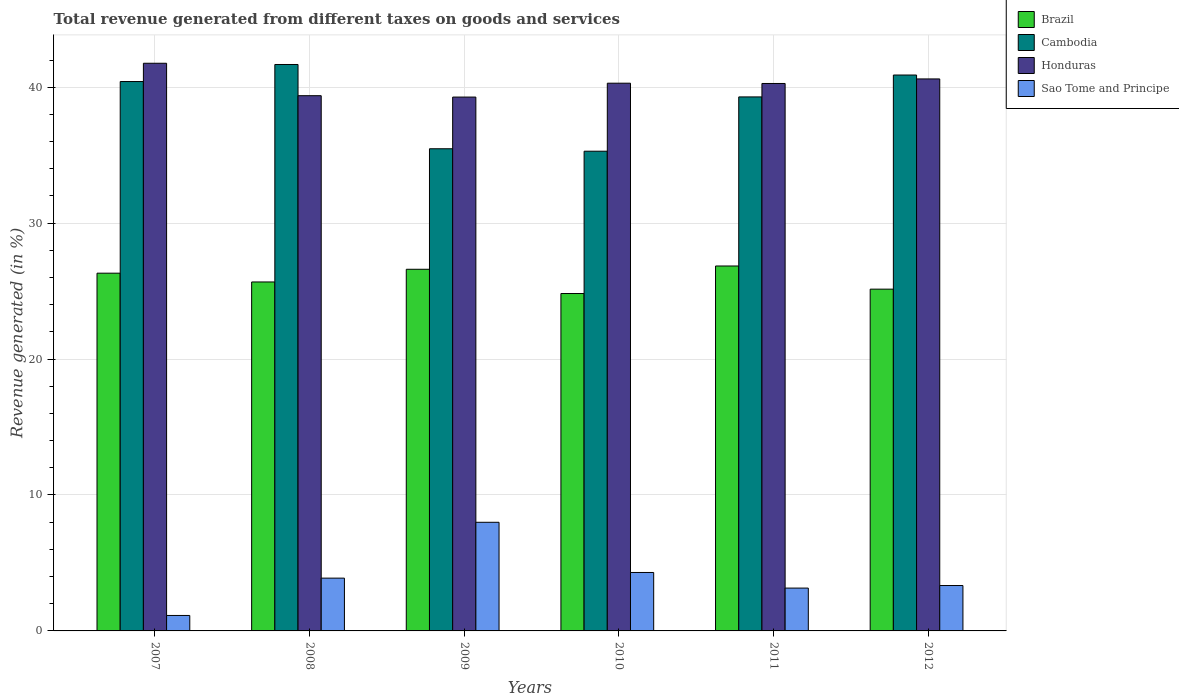How many groups of bars are there?
Your answer should be compact. 6. Are the number of bars on each tick of the X-axis equal?
Give a very brief answer. Yes. What is the label of the 1st group of bars from the left?
Your answer should be compact. 2007. What is the total revenue generated in Cambodia in 2008?
Your answer should be compact. 41.67. Across all years, what is the maximum total revenue generated in Cambodia?
Keep it short and to the point. 41.67. Across all years, what is the minimum total revenue generated in Sao Tome and Principe?
Provide a short and direct response. 1.14. In which year was the total revenue generated in Cambodia maximum?
Ensure brevity in your answer.  2008. In which year was the total revenue generated in Cambodia minimum?
Your response must be concise. 2010. What is the total total revenue generated in Honduras in the graph?
Give a very brief answer. 241.58. What is the difference between the total revenue generated in Cambodia in 2009 and that in 2012?
Your answer should be very brief. -5.42. What is the difference between the total revenue generated in Cambodia in 2008 and the total revenue generated in Honduras in 2010?
Your response must be concise. 1.38. What is the average total revenue generated in Sao Tome and Principe per year?
Make the answer very short. 3.97. In the year 2012, what is the difference between the total revenue generated in Brazil and total revenue generated in Honduras?
Your response must be concise. -15.47. What is the ratio of the total revenue generated in Brazil in 2011 to that in 2012?
Offer a terse response. 1.07. Is the total revenue generated in Honduras in 2008 less than that in 2011?
Offer a very short reply. Yes. What is the difference between the highest and the second highest total revenue generated in Honduras?
Keep it short and to the point. 1.15. What is the difference between the highest and the lowest total revenue generated in Cambodia?
Offer a very short reply. 6.38. In how many years, is the total revenue generated in Cambodia greater than the average total revenue generated in Cambodia taken over all years?
Ensure brevity in your answer.  4. Is it the case that in every year, the sum of the total revenue generated in Sao Tome and Principe and total revenue generated in Cambodia is greater than the sum of total revenue generated in Honduras and total revenue generated in Brazil?
Provide a short and direct response. No. What does the 3rd bar from the left in 2010 represents?
Your response must be concise. Honduras. What does the 2nd bar from the right in 2009 represents?
Offer a very short reply. Honduras. Is it the case that in every year, the sum of the total revenue generated in Brazil and total revenue generated in Honduras is greater than the total revenue generated in Cambodia?
Make the answer very short. Yes. How many bars are there?
Keep it short and to the point. 24. Are all the bars in the graph horizontal?
Provide a short and direct response. No. How many years are there in the graph?
Ensure brevity in your answer.  6. Are the values on the major ticks of Y-axis written in scientific E-notation?
Offer a very short reply. No. Does the graph contain any zero values?
Give a very brief answer. No. Does the graph contain grids?
Offer a terse response. Yes. How are the legend labels stacked?
Offer a terse response. Vertical. What is the title of the graph?
Your answer should be very brief. Total revenue generated from different taxes on goods and services. Does "Honduras" appear as one of the legend labels in the graph?
Give a very brief answer. Yes. What is the label or title of the X-axis?
Ensure brevity in your answer.  Years. What is the label or title of the Y-axis?
Ensure brevity in your answer.  Revenue generated (in %). What is the Revenue generated (in %) in Brazil in 2007?
Offer a terse response. 26.32. What is the Revenue generated (in %) of Cambodia in 2007?
Keep it short and to the point. 40.42. What is the Revenue generated (in %) in Honduras in 2007?
Your answer should be compact. 41.76. What is the Revenue generated (in %) of Sao Tome and Principe in 2007?
Your answer should be compact. 1.14. What is the Revenue generated (in %) in Brazil in 2008?
Provide a succinct answer. 25.67. What is the Revenue generated (in %) of Cambodia in 2008?
Make the answer very short. 41.67. What is the Revenue generated (in %) of Honduras in 2008?
Provide a succinct answer. 39.37. What is the Revenue generated (in %) in Sao Tome and Principe in 2008?
Offer a terse response. 3.88. What is the Revenue generated (in %) of Brazil in 2009?
Provide a short and direct response. 26.61. What is the Revenue generated (in %) of Cambodia in 2009?
Ensure brevity in your answer.  35.47. What is the Revenue generated (in %) of Honduras in 2009?
Give a very brief answer. 39.27. What is the Revenue generated (in %) in Sao Tome and Principe in 2009?
Your response must be concise. 7.99. What is the Revenue generated (in %) of Brazil in 2010?
Provide a succinct answer. 24.82. What is the Revenue generated (in %) in Cambodia in 2010?
Offer a terse response. 35.29. What is the Revenue generated (in %) of Honduras in 2010?
Offer a terse response. 40.29. What is the Revenue generated (in %) of Sao Tome and Principe in 2010?
Your response must be concise. 4.3. What is the Revenue generated (in %) of Brazil in 2011?
Keep it short and to the point. 26.85. What is the Revenue generated (in %) of Cambodia in 2011?
Give a very brief answer. 39.28. What is the Revenue generated (in %) of Honduras in 2011?
Keep it short and to the point. 40.27. What is the Revenue generated (in %) of Sao Tome and Principe in 2011?
Provide a succinct answer. 3.15. What is the Revenue generated (in %) of Brazil in 2012?
Your answer should be very brief. 25.14. What is the Revenue generated (in %) of Cambodia in 2012?
Your response must be concise. 40.9. What is the Revenue generated (in %) of Honduras in 2012?
Ensure brevity in your answer.  40.61. What is the Revenue generated (in %) of Sao Tome and Principe in 2012?
Offer a terse response. 3.34. Across all years, what is the maximum Revenue generated (in %) in Brazil?
Offer a very short reply. 26.85. Across all years, what is the maximum Revenue generated (in %) of Cambodia?
Keep it short and to the point. 41.67. Across all years, what is the maximum Revenue generated (in %) in Honduras?
Provide a short and direct response. 41.76. Across all years, what is the maximum Revenue generated (in %) of Sao Tome and Principe?
Provide a short and direct response. 7.99. Across all years, what is the minimum Revenue generated (in %) in Brazil?
Offer a terse response. 24.82. Across all years, what is the minimum Revenue generated (in %) in Cambodia?
Give a very brief answer. 35.29. Across all years, what is the minimum Revenue generated (in %) of Honduras?
Your answer should be compact. 39.27. Across all years, what is the minimum Revenue generated (in %) in Sao Tome and Principe?
Your answer should be very brief. 1.14. What is the total Revenue generated (in %) in Brazil in the graph?
Offer a very short reply. 155.4. What is the total Revenue generated (in %) in Cambodia in the graph?
Offer a terse response. 233.03. What is the total Revenue generated (in %) in Honduras in the graph?
Your answer should be compact. 241.58. What is the total Revenue generated (in %) in Sao Tome and Principe in the graph?
Your answer should be compact. 23.8. What is the difference between the Revenue generated (in %) of Brazil in 2007 and that in 2008?
Your answer should be compact. 0.65. What is the difference between the Revenue generated (in %) in Cambodia in 2007 and that in 2008?
Keep it short and to the point. -1.25. What is the difference between the Revenue generated (in %) in Honduras in 2007 and that in 2008?
Give a very brief answer. 2.39. What is the difference between the Revenue generated (in %) of Sao Tome and Principe in 2007 and that in 2008?
Offer a terse response. -2.75. What is the difference between the Revenue generated (in %) of Brazil in 2007 and that in 2009?
Provide a short and direct response. -0.29. What is the difference between the Revenue generated (in %) of Cambodia in 2007 and that in 2009?
Your answer should be compact. 4.95. What is the difference between the Revenue generated (in %) in Honduras in 2007 and that in 2009?
Your response must be concise. 2.49. What is the difference between the Revenue generated (in %) of Sao Tome and Principe in 2007 and that in 2009?
Your response must be concise. -6.85. What is the difference between the Revenue generated (in %) of Brazil in 2007 and that in 2010?
Provide a succinct answer. 1.5. What is the difference between the Revenue generated (in %) in Cambodia in 2007 and that in 2010?
Make the answer very short. 5.13. What is the difference between the Revenue generated (in %) in Honduras in 2007 and that in 2010?
Your answer should be very brief. 1.47. What is the difference between the Revenue generated (in %) in Sao Tome and Principe in 2007 and that in 2010?
Provide a short and direct response. -3.16. What is the difference between the Revenue generated (in %) in Brazil in 2007 and that in 2011?
Your response must be concise. -0.53. What is the difference between the Revenue generated (in %) in Cambodia in 2007 and that in 2011?
Your answer should be compact. 1.13. What is the difference between the Revenue generated (in %) of Honduras in 2007 and that in 2011?
Provide a short and direct response. 1.49. What is the difference between the Revenue generated (in %) in Sao Tome and Principe in 2007 and that in 2011?
Make the answer very short. -2.01. What is the difference between the Revenue generated (in %) of Brazil in 2007 and that in 2012?
Your response must be concise. 1.17. What is the difference between the Revenue generated (in %) of Cambodia in 2007 and that in 2012?
Give a very brief answer. -0.48. What is the difference between the Revenue generated (in %) of Honduras in 2007 and that in 2012?
Your response must be concise. 1.15. What is the difference between the Revenue generated (in %) of Sao Tome and Principe in 2007 and that in 2012?
Your answer should be very brief. -2.2. What is the difference between the Revenue generated (in %) of Brazil in 2008 and that in 2009?
Give a very brief answer. -0.93. What is the difference between the Revenue generated (in %) of Cambodia in 2008 and that in 2009?
Provide a succinct answer. 6.2. What is the difference between the Revenue generated (in %) of Honduras in 2008 and that in 2009?
Give a very brief answer. 0.1. What is the difference between the Revenue generated (in %) of Sao Tome and Principe in 2008 and that in 2009?
Offer a very short reply. -4.11. What is the difference between the Revenue generated (in %) of Brazil in 2008 and that in 2010?
Provide a short and direct response. 0.85. What is the difference between the Revenue generated (in %) in Cambodia in 2008 and that in 2010?
Offer a terse response. 6.38. What is the difference between the Revenue generated (in %) in Honduras in 2008 and that in 2010?
Your answer should be compact. -0.92. What is the difference between the Revenue generated (in %) of Sao Tome and Principe in 2008 and that in 2010?
Offer a very short reply. -0.42. What is the difference between the Revenue generated (in %) of Brazil in 2008 and that in 2011?
Your answer should be very brief. -1.18. What is the difference between the Revenue generated (in %) of Cambodia in 2008 and that in 2011?
Ensure brevity in your answer.  2.39. What is the difference between the Revenue generated (in %) in Honduras in 2008 and that in 2011?
Offer a terse response. -0.9. What is the difference between the Revenue generated (in %) of Sao Tome and Principe in 2008 and that in 2011?
Provide a succinct answer. 0.73. What is the difference between the Revenue generated (in %) in Brazil in 2008 and that in 2012?
Your answer should be compact. 0.53. What is the difference between the Revenue generated (in %) of Cambodia in 2008 and that in 2012?
Your response must be concise. 0.78. What is the difference between the Revenue generated (in %) in Honduras in 2008 and that in 2012?
Provide a short and direct response. -1.23. What is the difference between the Revenue generated (in %) of Sao Tome and Principe in 2008 and that in 2012?
Provide a succinct answer. 0.54. What is the difference between the Revenue generated (in %) of Brazil in 2009 and that in 2010?
Your answer should be compact. 1.78. What is the difference between the Revenue generated (in %) in Cambodia in 2009 and that in 2010?
Offer a very short reply. 0.18. What is the difference between the Revenue generated (in %) in Honduras in 2009 and that in 2010?
Your response must be concise. -1.02. What is the difference between the Revenue generated (in %) in Sao Tome and Principe in 2009 and that in 2010?
Offer a terse response. 3.69. What is the difference between the Revenue generated (in %) in Brazil in 2009 and that in 2011?
Provide a short and direct response. -0.24. What is the difference between the Revenue generated (in %) of Cambodia in 2009 and that in 2011?
Offer a terse response. -3.81. What is the difference between the Revenue generated (in %) of Honduras in 2009 and that in 2011?
Offer a very short reply. -1. What is the difference between the Revenue generated (in %) of Sao Tome and Principe in 2009 and that in 2011?
Provide a short and direct response. 4.84. What is the difference between the Revenue generated (in %) in Brazil in 2009 and that in 2012?
Offer a terse response. 1.46. What is the difference between the Revenue generated (in %) of Cambodia in 2009 and that in 2012?
Provide a short and direct response. -5.42. What is the difference between the Revenue generated (in %) in Honduras in 2009 and that in 2012?
Your response must be concise. -1.34. What is the difference between the Revenue generated (in %) of Sao Tome and Principe in 2009 and that in 2012?
Offer a terse response. 4.65. What is the difference between the Revenue generated (in %) of Brazil in 2010 and that in 2011?
Provide a succinct answer. -2.03. What is the difference between the Revenue generated (in %) of Cambodia in 2010 and that in 2011?
Make the answer very short. -3.99. What is the difference between the Revenue generated (in %) of Honduras in 2010 and that in 2011?
Your answer should be very brief. 0.02. What is the difference between the Revenue generated (in %) of Sao Tome and Principe in 2010 and that in 2011?
Ensure brevity in your answer.  1.15. What is the difference between the Revenue generated (in %) of Brazil in 2010 and that in 2012?
Ensure brevity in your answer.  -0.32. What is the difference between the Revenue generated (in %) in Cambodia in 2010 and that in 2012?
Your response must be concise. -5.6. What is the difference between the Revenue generated (in %) of Honduras in 2010 and that in 2012?
Offer a terse response. -0.31. What is the difference between the Revenue generated (in %) of Sao Tome and Principe in 2010 and that in 2012?
Your answer should be compact. 0.96. What is the difference between the Revenue generated (in %) in Brazil in 2011 and that in 2012?
Give a very brief answer. 1.7. What is the difference between the Revenue generated (in %) in Cambodia in 2011 and that in 2012?
Your answer should be very brief. -1.61. What is the difference between the Revenue generated (in %) in Honduras in 2011 and that in 2012?
Your answer should be very brief. -0.34. What is the difference between the Revenue generated (in %) of Sao Tome and Principe in 2011 and that in 2012?
Provide a succinct answer. -0.19. What is the difference between the Revenue generated (in %) in Brazil in 2007 and the Revenue generated (in %) in Cambodia in 2008?
Your response must be concise. -15.35. What is the difference between the Revenue generated (in %) of Brazil in 2007 and the Revenue generated (in %) of Honduras in 2008?
Make the answer very short. -13.06. What is the difference between the Revenue generated (in %) of Brazil in 2007 and the Revenue generated (in %) of Sao Tome and Principe in 2008?
Provide a short and direct response. 22.43. What is the difference between the Revenue generated (in %) of Cambodia in 2007 and the Revenue generated (in %) of Honduras in 2008?
Your response must be concise. 1.04. What is the difference between the Revenue generated (in %) of Cambodia in 2007 and the Revenue generated (in %) of Sao Tome and Principe in 2008?
Give a very brief answer. 36.53. What is the difference between the Revenue generated (in %) of Honduras in 2007 and the Revenue generated (in %) of Sao Tome and Principe in 2008?
Ensure brevity in your answer.  37.88. What is the difference between the Revenue generated (in %) in Brazil in 2007 and the Revenue generated (in %) in Cambodia in 2009?
Make the answer very short. -9.15. What is the difference between the Revenue generated (in %) of Brazil in 2007 and the Revenue generated (in %) of Honduras in 2009?
Ensure brevity in your answer.  -12.96. What is the difference between the Revenue generated (in %) of Brazil in 2007 and the Revenue generated (in %) of Sao Tome and Principe in 2009?
Keep it short and to the point. 18.33. What is the difference between the Revenue generated (in %) of Cambodia in 2007 and the Revenue generated (in %) of Honduras in 2009?
Make the answer very short. 1.14. What is the difference between the Revenue generated (in %) in Cambodia in 2007 and the Revenue generated (in %) in Sao Tome and Principe in 2009?
Your answer should be very brief. 32.42. What is the difference between the Revenue generated (in %) in Honduras in 2007 and the Revenue generated (in %) in Sao Tome and Principe in 2009?
Your response must be concise. 33.77. What is the difference between the Revenue generated (in %) of Brazil in 2007 and the Revenue generated (in %) of Cambodia in 2010?
Offer a terse response. -8.97. What is the difference between the Revenue generated (in %) of Brazil in 2007 and the Revenue generated (in %) of Honduras in 2010?
Offer a terse response. -13.98. What is the difference between the Revenue generated (in %) in Brazil in 2007 and the Revenue generated (in %) in Sao Tome and Principe in 2010?
Give a very brief answer. 22.02. What is the difference between the Revenue generated (in %) in Cambodia in 2007 and the Revenue generated (in %) in Honduras in 2010?
Your answer should be compact. 0.12. What is the difference between the Revenue generated (in %) of Cambodia in 2007 and the Revenue generated (in %) of Sao Tome and Principe in 2010?
Provide a short and direct response. 36.12. What is the difference between the Revenue generated (in %) in Honduras in 2007 and the Revenue generated (in %) in Sao Tome and Principe in 2010?
Your response must be concise. 37.46. What is the difference between the Revenue generated (in %) in Brazil in 2007 and the Revenue generated (in %) in Cambodia in 2011?
Keep it short and to the point. -12.97. What is the difference between the Revenue generated (in %) of Brazil in 2007 and the Revenue generated (in %) of Honduras in 2011?
Keep it short and to the point. -13.96. What is the difference between the Revenue generated (in %) of Brazil in 2007 and the Revenue generated (in %) of Sao Tome and Principe in 2011?
Your answer should be compact. 23.17. What is the difference between the Revenue generated (in %) in Cambodia in 2007 and the Revenue generated (in %) in Honduras in 2011?
Provide a short and direct response. 0.14. What is the difference between the Revenue generated (in %) of Cambodia in 2007 and the Revenue generated (in %) of Sao Tome and Principe in 2011?
Keep it short and to the point. 37.27. What is the difference between the Revenue generated (in %) in Honduras in 2007 and the Revenue generated (in %) in Sao Tome and Principe in 2011?
Keep it short and to the point. 38.61. What is the difference between the Revenue generated (in %) in Brazil in 2007 and the Revenue generated (in %) in Cambodia in 2012?
Offer a very short reply. -14.58. What is the difference between the Revenue generated (in %) in Brazil in 2007 and the Revenue generated (in %) in Honduras in 2012?
Your answer should be very brief. -14.29. What is the difference between the Revenue generated (in %) in Brazil in 2007 and the Revenue generated (in %) in Sao Tome and Principe in 2012?
Offer a terse response. 22.98. What is the difference between the Revenue generated (in %) of Cambodia in 2007 and the Revenue generated (in %) of Honduras in 2012?
Make the answer very short. -0.19. What is the difference between the Revenue generated (in %) of Cambodia in 2007 and the Revenue generated (in %) of Sao Tome and Principe in 2012?
Provide a short and direct response. 37.08. What is the difference between the Revenue generated (in %) in Honduras in 2007 and the Revenue generated (in %) in Sao Tome and Principe in 2012?
Your response must be concise. 38.42. What is the difference between the Revenue generated (in %) of Brazil in 2008 and the Revenue generated (in %) of Cambodia in 2009?
Make the answer very short. -9.8. What is the difference between the Revenue generated (in %) of Brazil in 2008 and the Revenue generated (in %) of Honduras in 2009?
Offer a very short reply. -13.6. What is the difference between the Revenue generated (in %) in Brazil in 2008 and the Revenue generated (in %) in Sao Tome and Principe in 2009?
Your response must be concise. 17.68. What is the difference between the Revenue generated (in %) in Cambodia in 2008 and the Revenue generated (in %) in Honduras in 2009?
Keep it short and to the point. 2.4. What is the difference between the Revenue generated (in %) in Cambodia in 2008 and the Revenue generated (in %) in Sao Tome and Principe in 2009?
Offer a very short reply. 33.68. What is the difference between the Revenue generated (in %) in Honduras in 2008 and the Revenue generated (in %) in Sao Tome and Principe in 2009?
Provide a short and direct response. 31.38. What is the difference between the Revenue generated (in %) of Brazil in 2008 and the Revenue generated (in %) of Cambodia in 2010?
Provide a short and direct response. -9.62. What is the difference between the Revenue generated (in %) in Brazil in 2008 and the Revenue generated (in %) in Honduras in 2010?
Provide a short and direct response. -14.62. What is the difference between the Revenue generated (in %) in Brazil in 2008 and the Revenue generated (in %) in Sao Tome and Principe in 2010?
Offer a very short reply. 21.37. What is the difference between the Revenue generated (in %) of Cambodia in 2008 and the Revenue generated (in %) of Honduras in 2010?
Provide a short and direct response. 1.38. What is the difference between the Revenue generated (in %) in Cambodia in 2008 and the Revenue generated (in %) in Sao Tome and Principe in 2010?
Your response must be concise. 37.37. What is the difference between the Revenue generated (in %) of Honduras in 2008 and the Revenue generated (in %) of Sao Tome and Principe in 2010?
Keep it short and to the point. 35.08. What is the difference between the Revenue generated (in %) of Brazil in 2008 and the Revenue generated (in %) of Cambodia in 2011?
Keep it short and to the point. -13.61. What is the difference between the Revenue generated (in %) in Brazil in 2008 and the Revenue generated (in %) in Honduras in 2011?
Offer a terse response. -14.6. What is the difference between the Revenue generated (in %) of Brazil in 2008 and the Revenue generated (in %) of Sao Tome and Principe in 2011?
Your answer should be compact. 22.52. What is the difference between the Revenue generated (in %) in Cambodia in 2008 and the Revenue generated (in %) in Honduras in 2011?
Keep it short and to the point. 1.4. What is the difference between the Revenue generated (in %) of Cambodia in 2008 and the Revenue generated (in %) of Sao Tome and Principe in 2011?
Your response must be concise. 38.52. What is the difference between the Revenue generated (in %) in Honduras in 2008 and the Revenue generated (in %) in Sao Tome and Principe in 2011?
Keep it short and to the point. 36.22. What is the difference between the Revenue generated (in %) in Brazil in 2008 and the Revenue generated (in %) in Cambodia in 2012?
Offer a very short reply. -15.22. What is the difference between the Revenue generated (in %) of Brazil in 2008 and the Revenue generated (in %) of Honduras in 2012?
Give a very brief answer. -14.94. What is the difference between the Revenue generated (in %) in Brazil in 2008 and the Revenue generated (in %) in Sao Tome and Principe in 2012?
Provide a succinct answer. 22.33. What is the difference between the Revenue generated (in %) of Cambodia in 2008 and the Revenue generated (in %) of Honduras in 2012?
Give a very brief answer. 1.06. What is the difference between the Revenue generated (in %) in Cambodia in 2008 and the Revenue generated (in %) in Sao Tome and Principe in 2012?
Your answer should be compact. 38.33. What is the difference between the Revenue generated (in %) in Honduras in 2008 and the Revenue generated (in %) in Sao Tome and Principe in 2012?
Provide a short and direct response. 36.03. What is the difference between the Revenue generated (in %) of Brazil in 2009 and the Revenue generated (in %) of Cambodia in 2010?
Provide a short and direct response. -8.69. What is the difference between the Revenue generated (in %) in Brazil in 2009 and the Revenue generated (in %) in Honduras in 2010?
Keep it short and to the point. -13.69. What is the difference between the Revenue generated (in %) of Brazil in 2009 and the Revenue generated (in %) of Sao Tome and Principe in 2010?
Provide a short and direct response. 22.31. What is the difference between the Revenue generated (in %) in Cambodia in 2009 and the Revenue generated (in %) in Honduras in 2010?
Give a very brief answer. -4.82. What is the difference between the Revenue generated (in %) in Cambodia in 2009 and the Revenue generated (in %) in Sao Tome and Principe in 2010?
Offer a very short reply. 31.17. What is the difference between the Revenue generated (in %) of Honduras in 2009 and the Revenue generated (in %) of Sao Tome and Principe in 2010?
Offer a terse response. 34.97. What is the difference between the Revenue generated (in %) in Brazil in 2009 and the Revenue generated (in %) in Cambodia in 2011?
Ensure brevity in your answer.  -12.68. What is the difference between the Revenue generated (in %) in Brazil in 2009 and the Revenue generated (in %) in Honduras in 2011?
Your answer should be very brief. -13.67. What is the difference between the Revenue generated (in %) of Brazil in 2009 and the Revenue generated (in %) of Sao Tome and Principe in 2011?
Provide a succinct answer. 23.45. What is the difference between the Revenue generated (in %) in Cambodia in 2009 and the Revenue generated (in %) in Honduras in 2011?
Give a very brief answer. -4.8. What is the difference between the Revenue generated (in %) in Cambodia in 2009 and the Revenue generated (in %) in Sao Tome and Principe in 2011?
Your response must be concise. 32.32. What is the difference between the Revenue generated (in %) in Honduras in 2009 and the Revenue generated (in %) in Sao Tome and Principe in 2011?
Your response must be concise. 36.12. What is the difference between the Revenue generated (in %) of Brazil in 2009 and the Revenue generated (in %) of Cambodia in 2012?
Give a very brief answer. -14.29. What is the difference between the Revenue generated (in %) of Brazil in 2009 and the Revenue generated (in %) of Honduras in 2012?
Give a very brief answer. -14. What is the difference between the Revenue generated (in %) in Brazil in 2009 and the Revenue generated (in %) in Sao Tome and Principe in 2012?
Your answer should be compact. 23.27. What is the difference between the Revenue generated (in %) of Cambodia in 2009 and the Revenue generated (in %) of Honduras in 2012?
Provide a short and direct response. -5.14. What is the difference between the Revenue generated (in %) in Cambodia in 2009 and the Revenue generated (in %) in Sao Tome and Principe in 2012?
Offer a terse response. 32.13. What is the difference between the Revenue generated (in %) in Honduras in 2009 and the Revenue generated (in %) in Sao Tome and Principe in 2012?
Provide a succinct answer. 35.93. What is the difference between the Revenue generated (in %) in Brazil in 2010 and the Revenue generated (in %) in Cambodia in 2011?
Make the answer very short. -14.46. What is the difference between the Revenue generated (in %) in Brazil in 2010 and the Revenue generated (in %) in Honduras in 2011?
Ensure brevity in your answer.  -15.45. What is the difference between the Revenue generated (in %) of Brazil in 2010 and the Revenue generated (in %) of Sao Tome and Principe in 2011?
Keep it short and to the point. 21.67. What is the difference between the Revenue generated (in %) of Cambodia in 2010 and the Revenue generated (in %) of Honduras in 2011?
Provide a succinct answer. -4.98. What is the difference between the Revenue generated (in %) of Cambodia in 2010 and the Revenue generated (in %) of Sao Tome and Principe in 2011?
Keep it short and to the point. 32.14. What is the difference between the Revenue generated (in %) of Honduras in 2010 and the Revenue generated (in %) of Sao Tome and Principe in 2011?
Offer a terse response. 37.14. What is the difference between the Revenue generated (in %) of Brazil in 2010 and the Revenue generated (in %) of Cambodia in 2012?
Offer a terse response. -16.07. What is the difference between the Revenue generated (in %) of Brazil in 2010 and the Revenue generated (in %) of Honduras in 2012?
Your answer should be very brief. -15.79. What is the difference between the Revenue generated (in %) in Brazil in 2010 and the Revenue generated (in %) in Sao Tome and Principe in 2012?
Make the answer very short. 21.48. What is the difference between the Revenue generated (in %) in Cambodia in 2010 and the Revenue generated (in %) in Honduras in 2012?
Provide a succinct answer. -5.32. What is the difference between the Revenue generated (in %) in Cambodia in 2010 and the Revenue generated (in %) in Sao Tome and Principe in 2012?
Your response must be concise. 31.95. What is the difference between the Revenue generated (in %) in Honduras in 2010 and the Revenue generated (in %) in Sao Tome and Principe in 2012?
Your answer should be very brief. 36.95. What is the difference between the Revenue generated (in %) of Brazil in 2011 and the Revenue generated (in %) of Cambodia in 2012?
Keep it short and to the point. -14.05. What is the difference between the Revenue generated (in %) in Brazil in 2011 and the Revenue generated (in %) in Honduras in 2012?
Your answer should be very brief. -13.76. What is the difference between the Revenue generated (in %) of Brazil in 2011 and the Revenue generated (in %) of Sao Tome and Principe in 2012?
Offer a terse response. 23.51. What is the difference between the Revenue generated (in %) of Cambodia in 2011 and the Revenue generated (in %) of Honduras in 2012?
Make the answer very short. -1.32. What is the difference between the Revenue generated (in %) of Cambodia in 2011 and the Revenue generated (in %) of Sao Tome and Principe in 2012?
Make the answer very short. 35.94. What is the difference between the Revenue generated (in %) in Honduras in 2011 and the Revenue generated (in %) in Sao Tome and Principe in 2012?
Offer a very short reply. 36.93. What is the average Revenue generated (in %) in Brazil per year?
Your response must be concise. 25.9. What is the average Revenue generated (in %) of Cambodia per year?
Your answer should be very brief. 38.84. What is the average Revenue generated (in %) of Honduras per year?
Keep it short and to the point. 40.26. What is the average Revenue generated (in %) in Sao Tome and Principe per year?
Make the answer very short. 3.97. In the year 2007, what is the difference between the Revenue generated (in %) of Brazil and Revenue generated (in %) of Cambodia?
Your answer should be compact. -14.1. In the year 2007, what is the difference between the Revenue generated (in %) of Brazil and Revenue generated (in %) of Honduras?
Ensure brevity in your answer.  -15.44. In the year 2007, what is the difference between the Revenue generated (in %) of Brazil and Revenue generated (in %) of Sao Tome and Principe?
Your answer should be very brief. 25.18. In the year 2007, what is the difference between the Revenue generated (in %) of Cambodia and Revenue generated (in %) of Honduras?
Provide a succinct answer. -1.34. In the year 2007, what is the difference between the Revenue generated (in %) of Cambodia and Revenue generated (in %) of Sao Tome and Principe?
Provide a succinct answer. 39.28. In the year 2007, what is the difference between the Revenue generated (in %) of Honduras and Revenue generated (in %) of Sao Tome and Principe?
Provide a short and direct response. 40.62. In the year 2008, what is the difference between the Revenue generated (in %) in Brazil and Revenue generated (in %) in Cambodia?
Your answer should be compact. -16. In the year 2008, what is the difference between the Revenue generated (in %) in Brazil and Revenue generated (in %) in Honduras?
Offer a terse response. -13.7. In the year 2008, what is the difference between the Revenue generated (in %) in Brazil and Revenue generated (in %) in Sao Tome and Principe?
Provide a succinct answer. 21.79. In the year 2008, what is the difference between the Revenue generated (in %) in Cambodia and Revenue generated (in %) in Honduras?
Keep it short and to the point. 2.3. In the year 2008, what is the difference between the Revenue generated (in %) of Cambodia and Revenue generated (in %) of Sao Tome and Principe?
Your answer should be very brief. 37.79. In the year 2008, what is the difference between the Revenue generated (in %) in Honduras and Revenue generated (in %) in Sao Tome and Principe?
Make the answer very short. 35.49. In the year 2009, what is the difference between the Revenue generated (in %) in Brazil and Revenue generated (in %) in Cambodia?
Provide a succinct answer. -8.87. In the year 2009, what is the difference between the Revenue generated (in %) of Brazil and Revenue generated (in %) of Honduras?
Offer a very short reply. -12.67. In the year 2009, what is the difference between the Revenue generated (in %) in Brazil and Revenue generated (in %) in Sao Tome and Principe?
Provide a short and direct response. 18.61. In the year 2009, what is the difference between the Revenue generated (in %) of Cambodia and Revenue generated (in %) of Honduras?
Offer a very short reply. -3.8. In the year 2009, what is the difference between the Revenue generated (in %) of Cambodia and Revenue generated (in %) of Sao Tome and Principe?
Give a very brief answer. 27.48. In the year 2009, what is the difference between the Revenue generated (in %) of Honduras and Revenue generated (in %) of Sao Tome and Principe?
Ensure brevity in your answer.  31.28. In the year 2010, what is the difference between the Revenue generated (in %) of Brazil and Revenue generated (in %) of Cambodia?
Your answer should be very brief. -10.47. In the year 2010, what is the difference between the Revenue generated (in %) of Brazil and Revenue generated (in %) of Honduras?
Your response must be concise. -15.47. In the year 2010, what is the difference between the Revenue generated (in %) of Brazil and Revenue generated (in %) of Sao Tome and Principe?
Give a very brief answer. 20.52. In the year 2010, what is the difference between the Revenue generated (in %) of Cambodia and Revenue generated (in %) of Honduras?
Ensure brevity in your answer.  -5. In the year 2010, what is the difference between the Revenue generated (in %) of Cambodia and Revenue generated (in %) of Sao Tome and Principe?
Ensure brevity in your answer.  30.99. In the year 2010, what is the difference between the Revenue generated (in %) in Honduras and Revenue generated (in %) in Sao Tome and Principe?
Give a very brief answer. 35.99. In the year 2011, what is the difference between the Revenue generated (in %) in Brazil and Revenue generated (in %) in Cambodia?
Offer a terse response. -12.44. In the year 2011, what is the difference between the Revenue generated (in %) in Brazil and Revenue generated (in %) in Honduras?
Your answer should be compact. -13.43. In the year 2011, what is the difference between the Revenue generated (in %) in Brazil and Revenue generated (in %) in Sao Tome and Principe?
Ensure brevity in your answer.  23.7. In the year 2011, what is the difference between the Revenue generated (in %) of Cambodia and Revenue generated (in %) of Honduras?
Your answer should be very brief. -0.99. In the year 2011, what is the difference between the Revenue generated (in %) in Cambodia and Revenue generated (in %) in Sao Tome and Principe?
Your response must be concise. 36.13. In the year 2011, what is the difference between the Revenue generated (in %) in Honduras and Revenue generated (in %) in Sao Tome and Principe?
Provide a short and direct response. 37.12. In the year 2012, what is the difference between the Revenue generated (in %) in Brazil and Revenue generated (in %) in Cambodia?
Keep it short and to the point. -15.75. In the year 2012, what is the difference between the Revenue generated (in %) in Brazil and Revenue generated (in %) in Honduras?
Offer a terse response. -15.47. In the year 2012, what is the difference between the Revenue generated (in %) in Brazil and Revenue generated (in %) in Sao Tome and Principe?
Your response must be concise. 21.8. In the year 2012, what is the difference between the Revenue generated (in %) of Cambodia and Revenue generated (in %) of Honduras?
Your answer should be compact. 0.29. In the year 2012, what is the difference between the Revenue generated (in %) in Cambodia and Revenue generated (in %) in Sao Tome and Principe?
Ensure brevity in your answer.  37.55. In the year 2012, what is the difference between the Revenue generated (in %) in Honduras and Revenue generated (in %) in Sao Tome and Principe?
Offer a terse response. 37.27. What is the ratio of the Revenue generated (in %) in Brazil in 2007 to that in 2008?
Provide a succinct answer. 1.03. What is the ratio of the Revenue generated (in %) in Cambodia in 2007 to that in 2008?
Provide a short and direct response. 0.97. What is the ratio of the Revenue generated (in %) in Honduras in 2007 to that in 2008?
Offer a terse response. 1.06. What is the ratio of the Revenue generated (in %) in Sao Tome and Principe in 2007 to that in 2008?
Give a very brief answer. 0.29. What is the ratio of the Revenue generated (in %) of Brazil in 2007 to that in 2009?
Your answer should be very brief. 0.99. What is the ratio of the Revenue generated (in %) of Cambodia in 2007 to that in 2009?
Provide a short and direct response. 1.14. What is the ratio of the Revenue generated (in %) of Honduras in 2007 to that in 2009?
Make the answer very short. 1.06. What is the ratio of the Revenue generated (in %) of Sao Tome and Principe in 2007 to that in 2009?
Your answer should be very brief. 0.14. What is the ratio of the Revenue generated (in %) of Brazil in 2007 to that in 2010?
Provide a short and direct response. 1.06. What is the ratio of the Revenue generated (in %) of Cambodia in 2007 to that in 2010?
Your response must be concise. 1.15. What is the ratio of the Revenue generated (in %) of Honduras in 2007 to that in 2010?
Offer a terse response. 1.04. What is the ratio of the Revenue generated (in %) in Sao Tome and Principe in 2007 to that in 2010?
Give a very brief answer. 0.26. What is the ratio of the Revenue generated (in %) of Brazil in 2007 to that in 2011?
Give a very brief answer. 0.98. What is the ratio of the Revenue generated (in %) of Cambodia in 2007 to that in 2011?
Make the answer very short. 1.03. What is the ratio of the Revenue generated (in %) in Honduras in 2007 to that in 2011?
Give a very brief answer. 1.04. What is the ratio of the Revenue generated (in %) in Sao Tome and Principe in 2007 to that in 2011?
Provide a succinct answer. 0.36. What is the ratio of the Revenue generated (in %) in Brazil in 2007 to that in 2012?
Offer a terse response. 1.05. What is the ratio of the Revenue generated (in %) of Cambodia in 2007 to that in 2012?
Keep it short and to the point. 0.99. What is the ratio of the Revenue generated (in %) in Honduras in 2007 to that in 2012?
Your answer should be compact. 1.03. What is the ratio of the Revenue generated (in %) of Sao Tome and Principe in 2007 to that in 2012?
Your answer should be compact. 0.34. What is the ratio of the Revenue generated (in %) of Brazil in 2008 to that in 2009?
Offer a terse response. 0.96. What is the ratio of the Revenue generated (in %) in Cambodia in 2008 to that in 2009?
Offer a very short reply. 1.17. What is the ratio of the Revenue generated (in %) of Sao Tome and Principe in 2008 to that in 2009?
Make the answer very short. 0.49. What is the ratio of the Revenue generated (in %) in Brazil in 2008 to that in 2010?
Offer a terse response. 1.03. What is the ratio of the Revenue generated (in %) in Cambodia in 2008 to that in 2010?
Ensure brevity in your answer.  1.18. What is the ratio of the Revenue generated (in %) of Honduras in 2008 to that in 2010?
Provide a short and direct response. 0.98. What is the ratio of the Revenue generated (in %) of Sao Tome and Principe in 2008 to that in 2010?
Provide a succinct answer. 0.9. What is the ratio of the Revenue generated (in %) of Brazil in 2008 to that in 2011?
Keep it short and to the point. 0.96. What is the ratio of the Revenue generated (in %) in Cambodia in 2008 to that in 2011?
Your response must be concise. 1.06. What is the ratio of the Revenue generated (in %) of Honduras in 2008 to that in 2011?
Provide a succinct answer. 0.98. What is the ratio of the Revenue generated (in %) in Sao Tome and Principe in 2008 to that in 2011?
Make the answer very short. 1.23. What is the ratio of the Revenue generated (in %) in Honduras in 2008 to that in 2012?
Keep it short and to the point. 0.97. What is the ratio of the Revenue generated (in %) of Sao Tome and Principe in 2008 to that in 2012?
Provide a short and direct response. 1.16. What is the ratio of the Revenue generated (in %) of Brazil in 2009 to that in 2010?
Give a very brief answer. 1.07. What is the ratio of the Revenue generated (in %) of Cambodia in 2009 to that in 2010?
Offer a terse response. 1.01. What is the ratio of the Revenue generated (in %) of Honduras in 2009 to that in 2010?
Your response must be concise. 0.97. What is the ratio of the Revenue generated (in %) in Sao Tome and Principe in 2009 to that in 2010?
Keep it short and to the point. 1.86. What is the ratio of the Revenue generated (in %) in Cambodia in 2009 to that in 2011?
Give a very brief answer. 0.9. What is the ratio of the Revenue generated (in %) in Honduras in 2009 to that in 2011?
Provide a succinct answer. 0.98. What is the ratio of the Revenue generated (in %) of Sao Tome and Principe in 2009 to that in 2011?
Provide a short and direct response. 2.54. What is the ratio of the Revenue generated (in %) in Brazil in 2009 to that in 2012?
Provide a short and direct response. 1.06. What is the ratio of the Revenue generated (in %) of Cambodia in 2009 to that in 2012?
Keep it short and to the point. 0.87. What is the ratio of the Revenue generated (in %) in Honduras in 2009 to that in 2012?
Provide a succinct answer. 0.97. What is the ratio of the Revenue generated (in %) of Sao Tome and Principe in 2009 to that in 2012?
Offer a very short reply. 2.39. What is the ratio of the Revenue generated (in %) of Brazil in 2010 to that in 2011?
Provide a short and direct response. 0.92. What is the ratio of the Revenue generated (in %) in Cambodia in 2010 to that in 2011?
Keep it short and to the point. 0.9. What is the ratio of the Revenue generated (in %) of Sao Tome and Principe in 2010 to that in 2011?
Ensure brevity in your answer.  1.36. What is the ratio of the Revenue generated (in %) in Brazil in 2010 to that in 2012?
Your response must be concise. 0.99. What is the ratio of the Revenue generated (in %) of Cambodia in 2010 to that in 2012?
Keep it short and to the point. 0.86. What is the ratio of the Revenue generated (in %) in Sao Tome and Principe in 2010 to that in 2012?
Offer a terse response. 1.29. What is the ratio of the Revenue generated (in %) in Brazil in 2011 to that in 2012?
Your response must be concise. 1.07. What is the ratio of the Revenue generated (in %) of Cambodia in 2011 to that in 2012?
Make the answer very short. 0.96. What is the ratio of the Revenue generated (in %) in Honduras in 2011 to that in 2012?
Provide a short and direct response. 0.99. What is the ratio of the Revenue generated (in %) in Sao Tome and Principe in 2011 to that in 2012?
Keep it short and to the point. 0.94. What is the difference between the highest and the second highest Revenue generated (in %) of Brazil?
Offer a terse response. 0.24. What is the difference between the highest and the second highest Revenue generated (in %) of Cambodia?
Make the answer very short. 0.78. What is the difference between the highest and the second highest Revenue generated (in %) in Honduras?
Provide a succinct answer. 1.15. What is the difference between the highest and the second highest Revenue generated (in %) of Sao Tome and Principe?
Keep it short and to the point. 3.69. What is the difference between the highest and the lowest Revenue generated (in %) of Brazil?
Your answer should be compact. 2.03. What is the difference between the highest and the lowest Revenue generated (in %) in Cambodia?
Your answer should be very brief. 6.38. What is the difference between the highest and the lowest Revenue generated (in %) in Honduras?
Give a very brief answer. 2.49. What is the difference between the highest and the lowest Revenue generated (in %) of Sao Tome and Principe?
Offer a terse response. 6.85. 